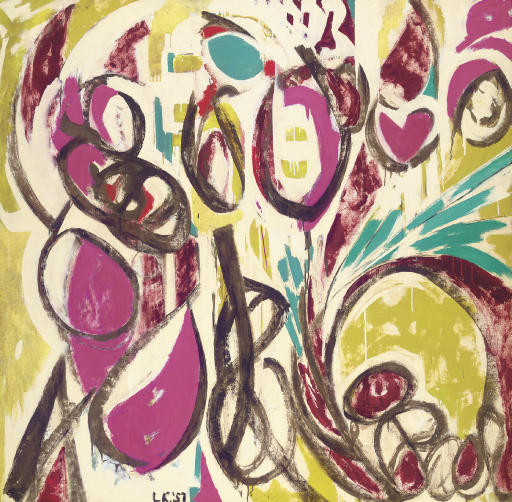Can you describe the emotions this artwork evokes? This artwork evokes a range of emotions due to its vibrant and dynamic composition. The energetic brushstrokes and bold colors create a sense of excitement and passion. It exudes a feeling of chaos and spontaneity, suggesting emotions of joy, freedom, and unrestrained creativity. The contrast between the dark, bold lines and the bright, popping colors can also invoke a sense of conflict and resolution, giving the viewer a journey through a spectrum of emotions. 